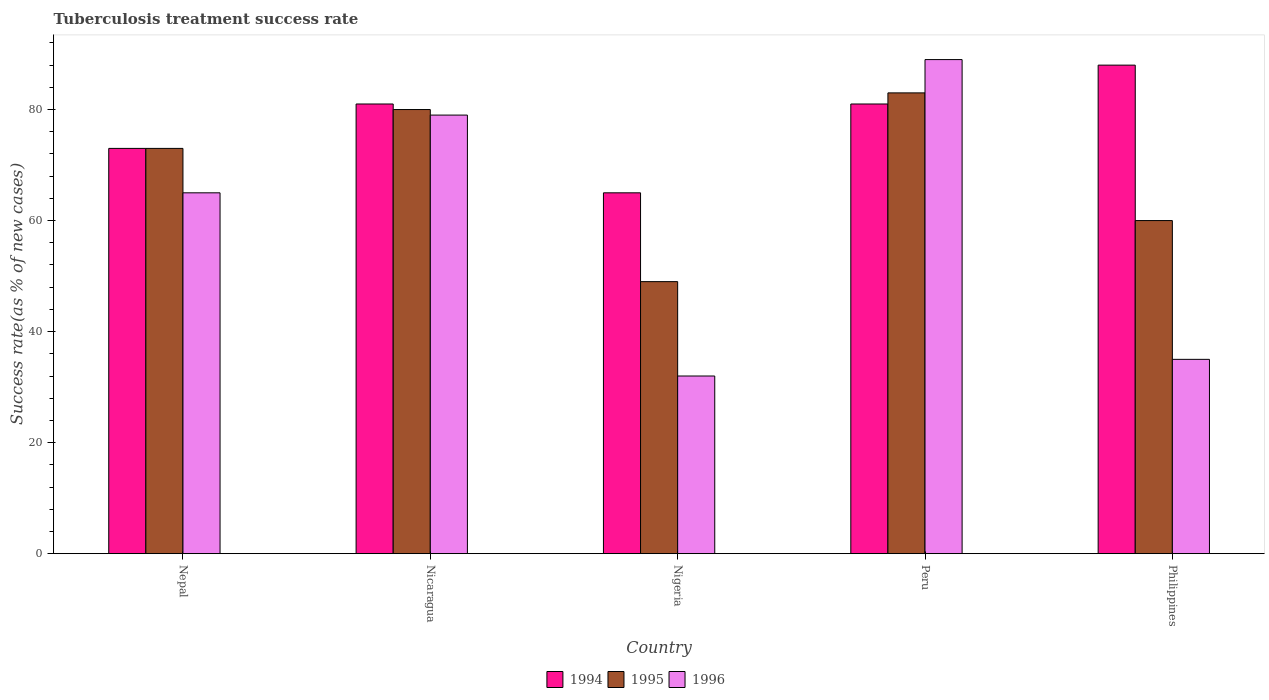How many different coloured bars are there?
Provide a short and direct response. 3. How many groups of bars are there?
Keep it short and to the point. 5. Are the number of bars per tick equal to the number of legend labels?
Provide a short and direct response. Yes. How many bars are there on the 3rd tick from the left?
Ensure brevity in your answer.  3. What is the label of the 1st group of bars from the left?
Make the answer very short. Nepal. Across all countries, what is the maximum tuberculosis treatment success rate in 1995?
Provide a succinct answer. 83. In which country was the tuberculosis treatment success rate in 1994 minimum?
Make the answer very short. Nigeria. What is the total tuberculosis treatment success rate in 1995 in the graph?
Provide a short and direct response. 345. What is the difference between the tuberculosis treatment success rate in 1995 in Nigeria and that in Philippines?
Keep it short and to the point. -11. What is the difference between the tuberculosis treatment success rate in 1995 in Nigeria and the tuberculosis treatment success rate in 1994 in Nicaragua?
Make the answer very short. -32. What is the average tuberculosis treatment success rate in 1995 per country?
Offer a very short reply. 69. What is the difference between the tuberculosis treatment success rate of/in 1995 and tuberculosis treatment success rate of/in 1996 in Nepal?
Keep it short and to the point. 8. In how many countries, is the tuberculosis treatment success rate in 1996 greater than 12 %?
Keep it short and to the point. 5. What is the ratio of the tuberculosis treatment success rate in 1994 in Nigeria to that in Peru?
Provide a succinct answer. 0.8. Is the tuberculosis treatment success rate in 1995 in Nicaragua less than that in Nigeria?
Provide a short and direct response. No. Is the difference between the tuberculosis treatment success rate in 1995 in Nepal and Philippines greater than the difference between the tuberculosis treatment success rate in 1996 in Nepal and Philippines?
Offer a terse response. No. In how many countries, is the tuberculosis treatment success rate in 1994 greater than the average tuberculosis treatment success rate in 1994 taken over all countries?
Make the answer very short. 3. Is the sum of the tuberculosis treatment success rate in 1994 in Nepal and Nigeria greater than the maximum tuberculosis treatment success rate in 1995 across all countries?
Your answer should be very brief. Yes. What is the difference between two consecutive major ticks on the Y-axis?
Offer a very short reply. 20. Are the values on the major ticks of Y-axis written in scientific E-notation?
Keep it short and to the point. No. Does the graph contain any zero values?
Offer a terse response. No. How are the legend labels stacked?
Offer a very short reply. Horizontal. What is the title of the graph?
Ensure brevity in your answer.  Tuberculosis treatment success rate. What is the label or title of the Y-axis?
Your answer should be compact. Success rate(as % of new cases). What is the Success rate(as % of new cases) of 1994 in Nepal?
Your answer should be compact. 73. What is the Success rate(as % of new cases) of 1995 in Nepal?
Provide a succinct answer. 73. What is the Success rate(as % of new cases) of 1996 in Nepal?
Your response must be concise. 65. What is the Success rate(as % of new cases) in 1996 in Nicaragua?
Your answer should be compact. 79. What is the Success rate(as % of new cases) in 1995 in Nigeria?
Give a very brief answer. 49. What is the Success rate(as % of new cases) in 1994 in Peru?
Keep it short and to the point. 81. What is the Success rate(as % of new cases) of 1996 in Peru?
Make the answer very short. 89. What is the Success rate(as % of new cases) of 1994 in Philippines?
Provide a succinct answer. 88. What is the Success rate(as % of new cases) in 1996 in Philippines?
Give a very brief answer. 35. Across all countries, what is the maximum Success rate(as % of new cases) in 1994?
Make the answer very short. 88. Across all countries, what is the maximum Success rate(as % of new cases) in 1995?
Your response must be concise. 83. Across all countries, what is the maximum Success rate(as % of new cases) in 1996?
Offer a very short reply. 89. Across all countries, what is the minimum Success rate(as % of new cases) of 1994?
Give a very brief answer. 65. Across all countries, what is the minimum Success rate(as % of new cases) of 1995?
Your answer should be compact. 49. What is the total Success rate(as % of new cases) in 1994 in the graph?
Give a very brief answer. 388. What is the total Success rate(as % of new cases) of 1995 in the graph?
Your answer should be very brief. 345. What is the total Success rate(as % of new cases) of 1996 in the graph?
Provide a short and direct response. 300. What is the difference between the Success rate(as % of new cases) in 1994 in Nepal and that in Nicaragua?
Your response must be concise. -8. What is the difference between the Success rate(as % of new cases) in 1996 in Nepal and that in Nicaragua?
Your answer should be very brief. -14. What is the difference between the Success rate(as % of new cases) of 1994 in Nepal and that in Nigeria?
Give a very brief answer. 8. What is the difference between the Success rate(as % of new cases) in 1996 in Nepal and that in Nigeria?
Make the answer very short. 33. What is the difference between the Success rate(as % of new cases) of 1994 in Nepal and that in Peru?
Keep it short and to the point. -8. What is the difference between the Success rate(as % of new cases) of 1995 in Nepal and that in Peru?
Give a very brief answer. -10. What is the difference between the Success rate(as % of new cases) of 1994 in Nepal and that in Philippines?
Your response must be concise. -15. What is the difference between the Success rate(as % of new cases) in 1996 in Nicaragua and that in Nigeria?
Your answer should be very brief. 47. What is the difference between the Success rate(as % of new cases) of 1995 in Nicaragua and that in Peru?
Offer a very short reply. -3. What is the difference between the Success rate(as % of new cases) of 1996 in Nicaragua and that in Peru?
Provide a short and direct response. -10. What is the difference between the Success rate(as % of new cases) of 1994 in Nicaragua and that in Philippines?
Your response must be concise. -7. What is the difference between the Success rate(as % of new cases) of 1996 in Nicaragua and that in Philippines?
Provide a short and direct response. 44. What is the difference between the Success rate(as % of new cases) in 1994 in Nigeria and that in Peru?
Provide a succinct answer. -16. What is the difference between the Success rate(as % of new cases) of 1995 in Nigeria and that in Peru?
Ensure brevity in your answer.  -34. What is the difference between the Success rate(as % of new cases) in 1996 in Nigeria and that in Peru?
Your answer should be compact. -57. What is the difference between the Success rate(as % of new cases) of 1996 in Nigeria and that in Philippines?
Keep it short and to the point. -3. What is the difference between the Success rate(as % of new cases) of 1995 in Peru and that in Philippines?
Ensure brevity in your answer.  23. What is the difference between the Success rate(as % of new cases) in 1996 in Peru and that in Philippines?
Your answer should be very brief. 54. What is the difference between the Success rate(as % of new cases) in 1994 in Nepal and the Success rate(as % of new cases) in 1995 in Nicaragua?
Your response must be concise. -7. What is the difference between the Success rate(as % of new cases) of 1994 in Nepal and the Success rate(as % of new cases) of 1996 in Nicaragua?
Your answer should be very brief. -6. What is the difference between the Success rate(as % of new cases) of 1995 in Nepal and the Success rate(as % of new cases) of 1996 in Nicaragua?
Provide a short and direct response. -6. What is the difference between the Success rate(as % of new cases) in 1994 in Nepal and the Success rate(as % of new cases) in 1995 in Nigeria?
Provide a short and direct response. 24. What is the difference between the Success rate(as % of new cases) of 1994 in Nepal and the Success rate(as % of new cases) of 1996 in Nigeria?
Your response must be concise. 41. What is the difference between the Success rate(as % of new cases) of 1994 in Nepal and the Success rate(as % of new cases) of 1996 in Peru?
Offer a terse response. -16. What is the difference between the Success rate(as % of new cases) of 1995 in Nepal and the Success rate(as % of new cases) of 1996 in Peru?
Keep it short and to the point. -16. What is the difference between the Success rate(as % of new cases) of 1994 in Nepal and the Success rate(as % of new cases) of 1995 in Philippines?
Your answer should be compact. 13. What is the difference between the Success rate(as % of new cases) in 1994 in Nepal and the Success rate(as % of new cases) in 1996 in Philippines?
Your answer should be compact. 38. What is the difference between the Success rate(as % of new cases) of 1994 in Nicaragua and the Success rate(as % of new cases) of 1995 in Nigeria?
Provide a succinct answer. 32. What is the difference between the Success rate(as % of new cases) of 1994 in Nicaragua and the Success rate(as % of new cases) of 1996 in Nigeria?
Keep it short and to the point. 49. What is the difference between the Success rate(as % of new cases) of 1994 in Nicaragua and the Success rate(as % of new cases) of 1995 in Peru?
Ensure brevity in your answer.  -2. What is the difference between the Success rate(as % of new cases) in 1994 in Nicaragua and the Success rate(as % of new cases) in 1996 in Peru?
Your answer should be compact. -8. What is the difference between the Success rate(as % of new cases) of 1994 in Nicaragua and the Success rate(as % of new cases) of 1995 in Philippines?
Your answer should be compact. 21. What is the difference between the Success rate(as % of new cases) of 1994 in Nicaragua and the Success rate(as % of new cases) of 1996 in Philippines?
Provide a succinct answer. 46. What is the difference between the Success rate(as % of new cases) of 1995 in Nicaragua and the Success rate(as % of new cases) of 1996 in Philippines?
Your response must be concise. 45. What is the difference between the Success rate(as % of new cases) of 1994 in Nigeria and the Success rate(as % of new cases) of 1996 in Peru?
Keep it short and to the point. -24. What is the difference between the Success rate(as % of new cases) of 1995 in Nigeria and the Success rate(as % of new cases) of 1996 in Peru?
Offer a very short reply. -40. What is the difference between the Success rate(as % of new cases) of 1994 in Nigeria and the Success rate(as % of new cases) of 1995 in Philippines?
Ensure brevity in your answer.  5. What is the difference between the Success rate(as % of new cases) of 1995 in Nigeria and the Success rate(as % of new cases) of 1996 in Philippines?
Keep it short and to the point. 14. What is the difference between the Success rate(as % of new cases) in 1994 in Peru and the Success rate(as % of new cases) in 1996 in Philippines?
Provide a short and direct response. 46. What is the difference between the Success rate(as % of new cases) of 1995 in Peru and the Success rate(as % of new cases) of 1996 in Philippines?
Keep it short and to the point. 48. What is the average Success rate(as % of new cases) of 1994 per country?
Give a very brief answer. 77.6. What is the difference between the Success rate(as % of new cases) of 1995 and Success rate(as % of new cases) of 1996 in Nepal?
Offer a very short reply. 8. What is the difference between the Success rate(as % of new cases) of 1994 and Success rate(as % of new cases) of 1996 in Nicaragua?
Provide a succinct answer. 2. What is the difference between the Success rate(as % of new cases) of 1995 and Success rate(as % of new cases) of 1996 in Nicaragua?
Your response must be concise. 1. What is the difference between the Success rate(as % of new cases) of 1995 and Success rate(as % of new cases) of 1996 in Nigeria?
Give a very brief answer. 17. What is the difference between the Success rate(as % of new cases) of 1994 and Success rate(as % of new cases) of 1996 in Peru?
Your answer should be compact. -8. What is the difference between the Success rate(as % of new cases) of 1994 and Success rate(as % of new cases) of 1996 in Philippines?
Keep it short and to the point. 53. What is the ratio of the Success rate(as % of new cases) in 1994 in Nepal to that in Nicaragua?
Provide a succinct answer. 0.9. What is the ratio of the Success rate(as % of new cases) in 1995 in Nepal to that in Nicaragua?
Provide a short and direct response. 0.91. What is the ratio of the Success rate(as % of new cases) of 1996 in Nepal to that in Nicaragua?
Keep it short and to the point. 0.82. What is the ratio of the Success rate(as % of new cases) in 1994 in Nepal to that in Nigeria?
Offer a terse response. 1.12. What is the ratio of the Success rate(as % of new cases) of 1995 in Nepal to that in Nigeria?
Provide a succinct answer. 1.49. What is the ratio of the Success rate(as % of new cases) in 1996 in Nepal to that in Nigeria?
Offer a terse response. 2.03. What is the ratio of the Success rate(as % of new cases) of 1994 in Nepal to that in Peru?
Offer a terse response. 0.9. What is the ratio of the Success rate(as % of new cases) of 1995 in Nepal to that in Peru?
Provide a short and direct response. 0.88. What is the ratio of the Success rate(as % of new cases) of 1996 in Nepal to that in Peru?
Provide a short and direct response. 0.73. What is the ratio of the Success rate(as % of new cases) in 1994 in Nepal to that in Philippines?
Ensure brevity in your answer.  0.83. What is the ratio of the Success rate(as % of new cases) in 1995 in Nepal to that in Philippines?
Provide a succinct answer. 1.22. What is the ratio of the Success rate(as % of new cases) of 1996 in Nepal to that in Philippines?
Provide a short and direct response. 1.86. What is the ratio of the Success rate(as % of new cases) of 1994 in Nicaragua to that in Nigeria?
Your response must be concise. 1.25. What is the ratio of the Success rate(as % of new cases) of 1995 in Nicaragua to that in Nigeria?
Provide a short and direct response. 1.63. What is the ratio of the Success rate(as % of new cases) in 1996 in Nicaragua to that in Nigeria?
Offer a terse response. 2.47. What is the ratio of the Success rate(as % of new cases) of 1995 in Nicaragua to that in Peru?
Offer a terse response. 0.96. What is the ratio of the Success rate(as % of new cases) of 1996 in Nicaragua to that in Peru?
Make the answer very short. 0.89. What is the ratio of the Success rate(as % of new cases) in 1994 in Nicaragua to that in Philippines?
Provide a succinct answer. 0.92. What is the ratio of the Success rate(as % of new cases) in 1995 in Nicaragua to that in Philippines?
Make the answer very short. 1.33. What is the ratio of the Success rate(as % of new cases) of 1996 in Nicaragua to that in Philippines?
Your response must be concise. 2.26. What is the ratio of the Success rate(as % of new cases) of 1994 in Nigeria to that in Peru?
Your answer should be very brief. 0.8. What is the ratio of the Success rate(as % of new cases) in 1995 in Nigeria to that in Peru?
Provide a short and direct response. 0.59. What is the ratio of the Success rate(as % of new cases) in 1996 in Nigeria to that in Peru?
Provide a succinct answer. 0.36. What is the ratio of the Success rate(as % of new cases) in 1994 in Nigeria to that in Philippines?
Provide a short and direct response. 0.74. What is the ratio of the Success rate(as % of new cases) of 1995 in Nigeria to that in Philippines?
Keep it short and to the point. 0.82. What is the ratio of the Success rate(as % of new cases) in 1996 in Nigeria to that in Philippines?
Offer a very short reply. 0.91. What is the ratio of the Success rate(as % of new cases) in 1994 in Peru to that in Philippines?
Provide a short and direct response. 0.92. What is the ratio of the Success rate(as % of new cases) of 1995 in Peru to that in Philippines?
Give a very brief answer. 1.38. What is the ratio of the Success rate(as % of new cases) in 1996 in Peru to that in Philippines?
Offer a very short reply. 2.54. What is the difference between the highest and the second highest Success rate(as % of new cases) in 1994?
Offer a very short reply. 7. What is the difference between the highest and the second highest Success rate(as % of new cases) of 1995?
Your answer should be very brief. 3. What is the difference between the highest and the second highest Success rate(as % of new cases) of 1996?
Offer a terse response. 10. What is the difference between the highest and the lowest Success rate(as % of new cases) of 1996?
Give a very brief answer. 57. 